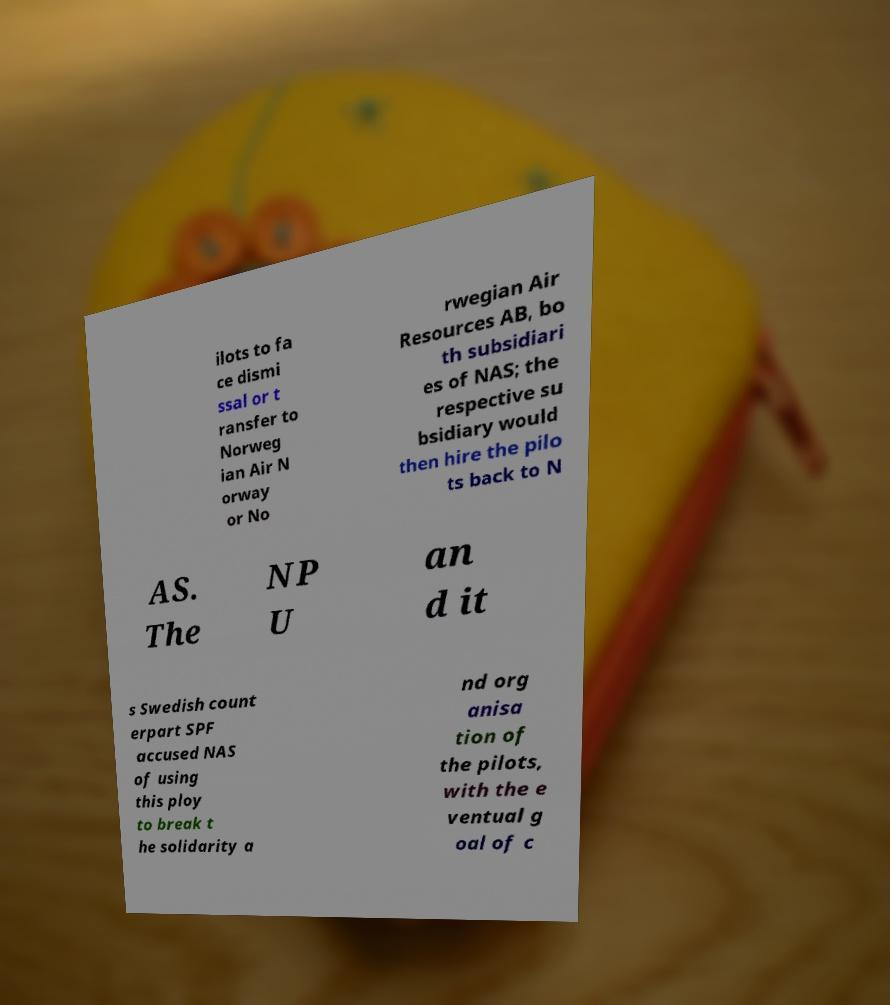Please read and relay the text visible in this image. What does it say? ilots to fa ce dismi ssal or t ransfer to Norweg ian Air N orway or No rwegian Air Resources AB, bo th subsidiari es of NAS; the respective su bsidiary would then hire the pilo ts back to N AS. The NP U an d it s Swedish count erpart SPF accused NAS of using this ploy to break t he solidarity a nd org anisa tion of the pilots, with the e ventual g oal of c 